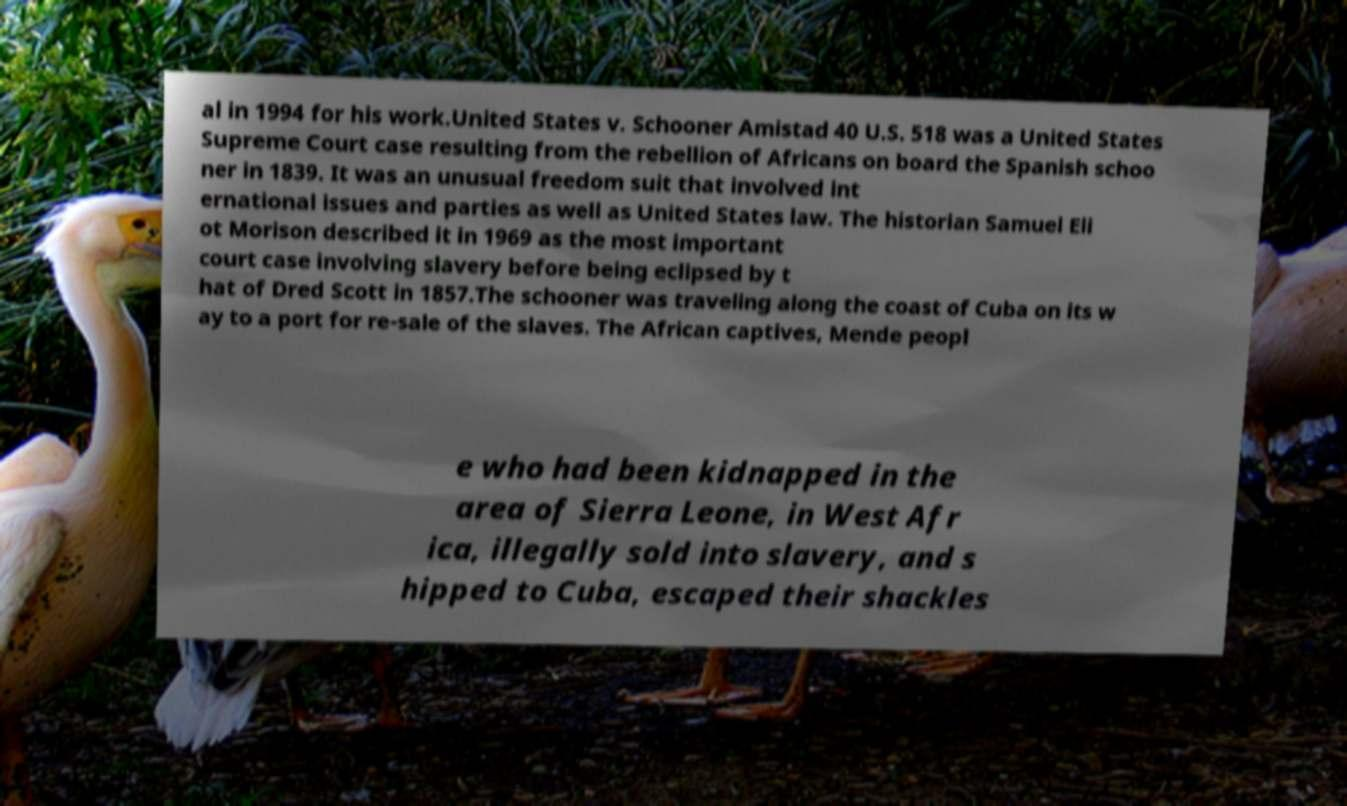I need the written content from this picture converted into text. Can you do that? al in 1994 for his work.United States v. Schooner Amistad 40 U.S. 518 was a United States Supreme Court case resulting from the rebellion of Africans on board the Spanish schoo ner in 1839. It was an unusual freedom suit that involved int ernational issues and parties as well as United States law. The historian Samuel Eli ot Morison described it in 1969 as the most important court case involving slavery before being eclipsed by t hat of Dred Scott in 1857.The schooner was traveling along the coast of Cuba on its w ay to a port for re-sale of the slaves. The African captives, Mende peopl e who had been kidnapped in the area of Sierra Leone, in West Afr ica, illegally sold into slavery, and s hipped to Cuba, escaped their shackles 